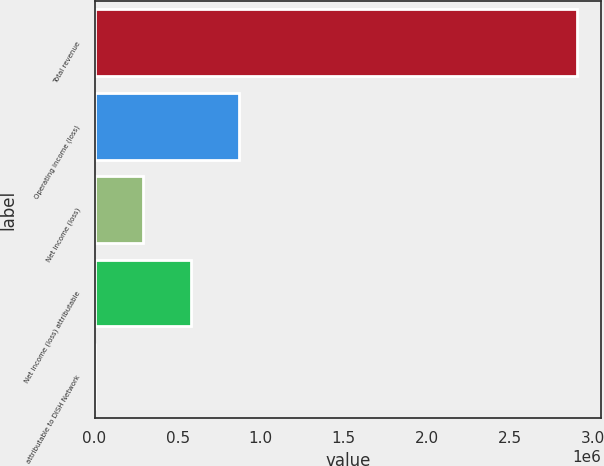Convert chart. <chart><loc_0><loc_0><loc_500><loc_500><bar_chart><fcel>Total revenue<fcel>Operating income (loss)<fcel>Net income (loss)<fcel>Net income (loss) attributable<fcel>attributable to DISH Network<nl><fcel>2.9037e+06<fcel>871110<fcel>290370<fcel>580740<fcel>0.14<nl></chart> 